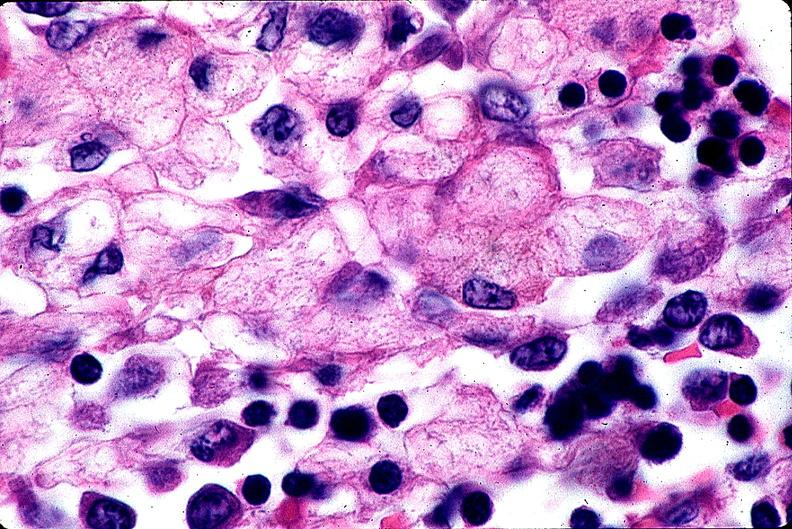s hematologic present?
Answer the question using a single word or phrase. Yes 